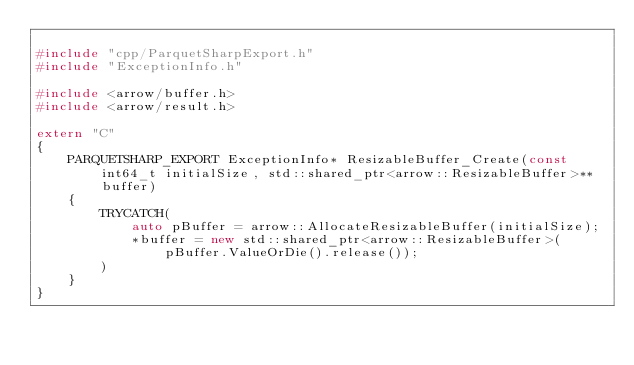Convert code to text. <code><loc_0><loc_0><loc_500><loc_500><_C++_>
#include "cpp/ParquetSharpExport.h"
#include "ExceptionInfo.h"

#include <arrow/buffer.h>
#include <arrow/result.h>

extern "C"
{
	PARQUETSHARP_EXPORT ExceptionInfo* ResizableBuffer_Create(const int64_t initialSize, std::shared_ptr<arrow::ResizableBuffer>** buffer)
	{
		TRYCATCH(
			auto pBuffer = arrow::AllocateResizableBuffer(initialSize);
			*buffer = new std::shared_ptr<arrow::ResizableBuffer>(pBuffer.ValueOrDie().release());
		)
	}
}
</code> 